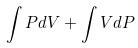<formula> <loc_0><loc_0><loc_500><loc_500>\int P d V + \int V d P</formula> 